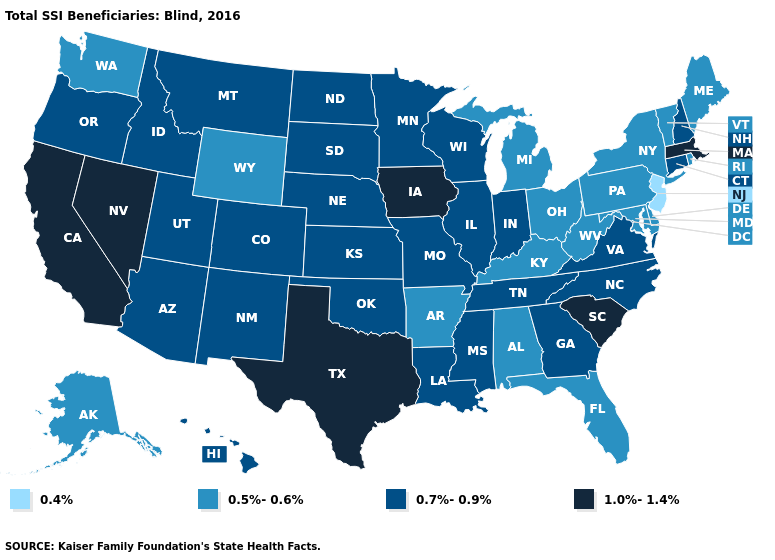Name the states that have a value in the range 0.5%-0.6%?
Keep it brief. Alabama, Alaska, Arkansas, Delaware, Florida, Kentucky, Maine, Maryland, Michigan, New York, Ohio, Pennsylvania, Rhode Island, Vermont, Washington, West Virginia, Wyoming. What is the lowest value in the USA?
Be succinct. 0.4%. Which states hav the highest value in the Northeast?
Quick response, please. Massachusetts. What is the value of Florida?
Answer briefly. 0.5%-0.6%. What is the lowest value in the USA?
Be succinct. 0.4%. Name the states that have a value in the range 1.0%-1.4%?
Keep it brief. California, Iowa, Massachusetts, Nevada, South Carolina, Texas. What is the value of North Dakota?
Keep it brief. 0.7%-0.9%. Does Michigan have a higher value than Kansas?
Concise answer only. No. Does Hawaii have the lowest value in the USA?
Answer briefly. No. Name the states that have a value in the range 0.7%-0.9%?
Give a very brief answer. Arizona, Colorado, Connecticut, Georgia, Hawaii, Idaho, Illinois, Indiana, Kansas, Louisiana, Minnesota, Mississippi, Missouri, Montana, Nebraska, New Hampshire, New Mexico, North Carolina, North Dakota, Oklahoma, Oregon, South Dakota, Tennessee, Utah, Virginia, Wisconsin. What is the lowest value in the USA?
Answer briefly. 0.4%. What is the value of Nebraska?
Be succinct. 0.7%-0.9%. Name the states that have a value in the range 1.0%-1.4%?
Write a very short answer. California, Iowa, Massachusetts, Nevada, South Carolina, Texas. Name the states that have a value in the range 1.0%-1.4%?
Give a very brief answer. California, Iowa, Massachusetts, Nevada, South Carolina, Texas. Name the states that have a value in the range 1.0%-1.4%?
Quick response, please. California, Iowa, Massachusetts, Nevada, South Carolina, Texas. 